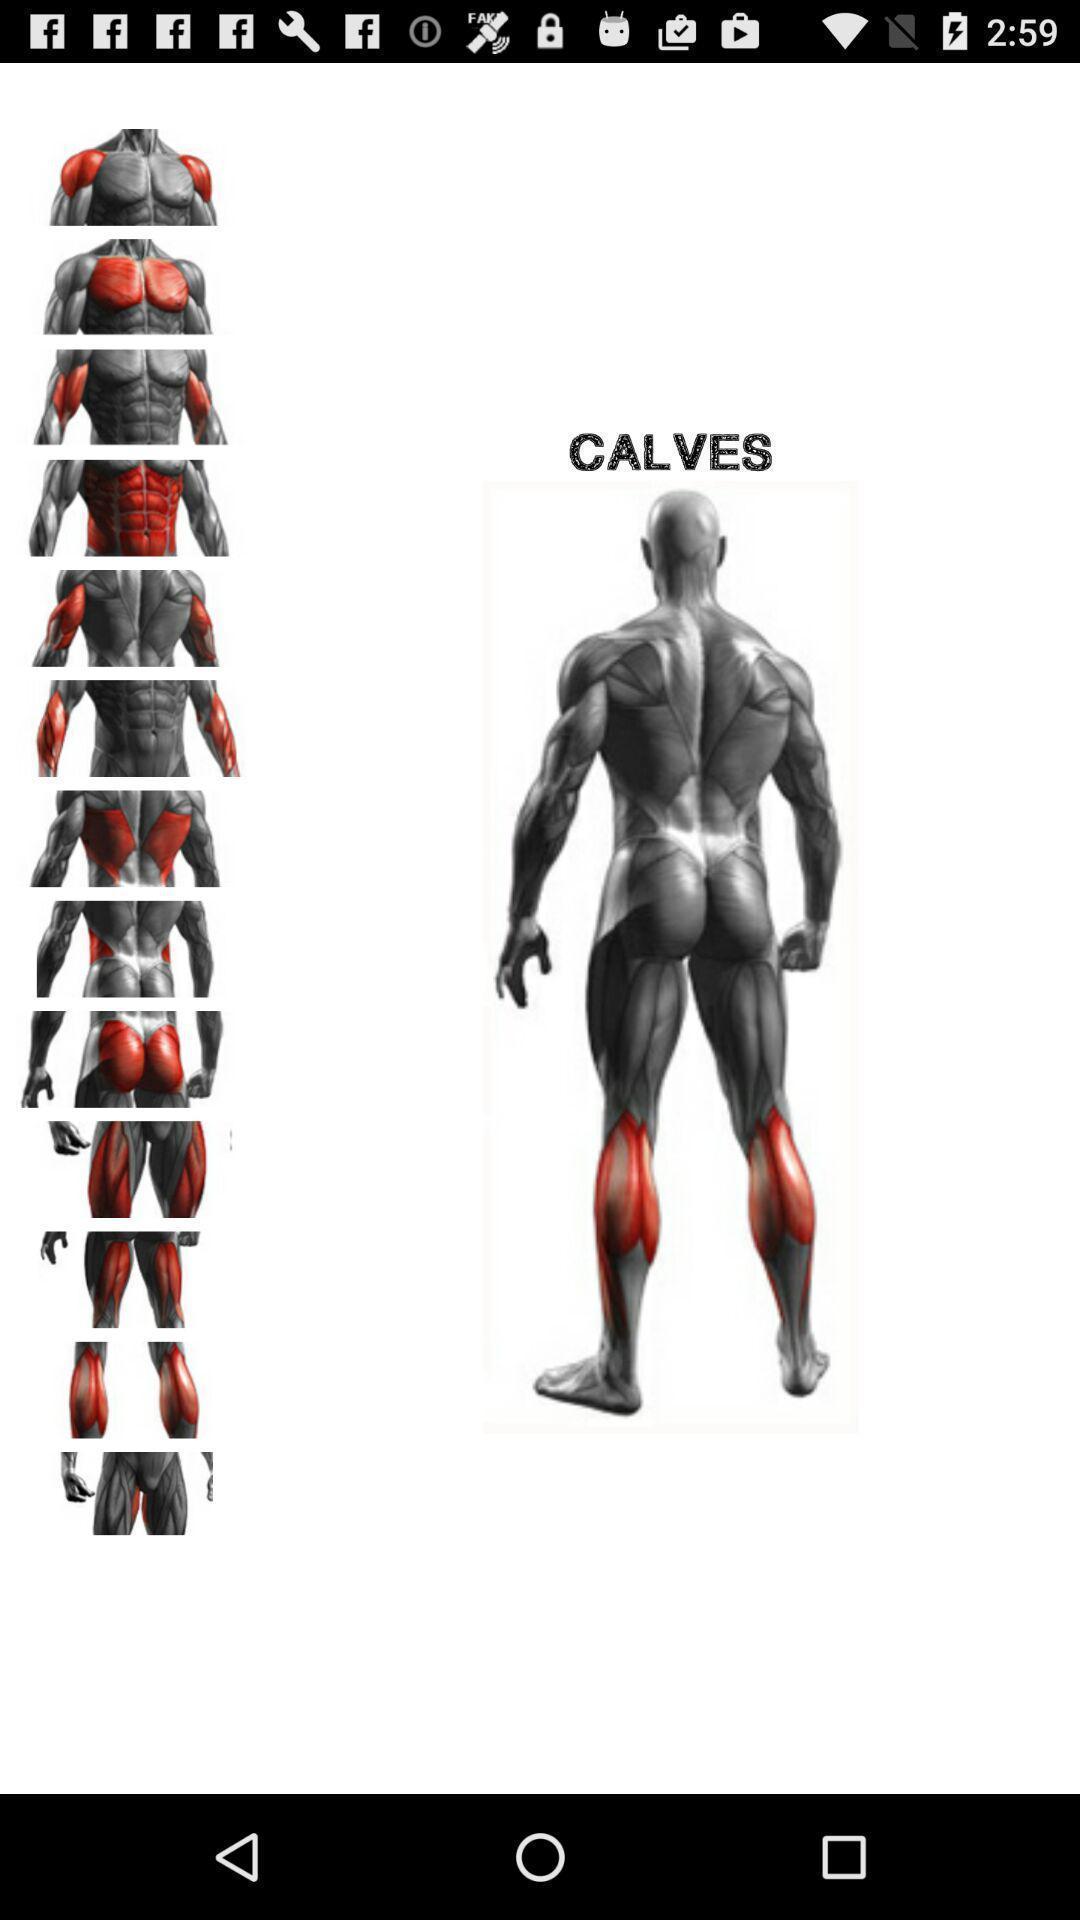What details can you identify in this image? Window displaying a bodybuilding app. 